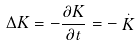<formula> <loc_0><loc_0><loc_500><loc_500>\Delta K = - \frac { \partial K } { \partial t } = - \stackrel { . } { K }</formula> 